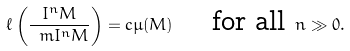Convert formula to latex. <formula><loc_0><loc_0><loc_500><loc_500>\ell \left ( \frac { I ^ { n } M } { \ m I ^ { n } M } \right ) = c \mu ( M ) \quad \ \text {for all} \ n \gg 0 .</formula> 